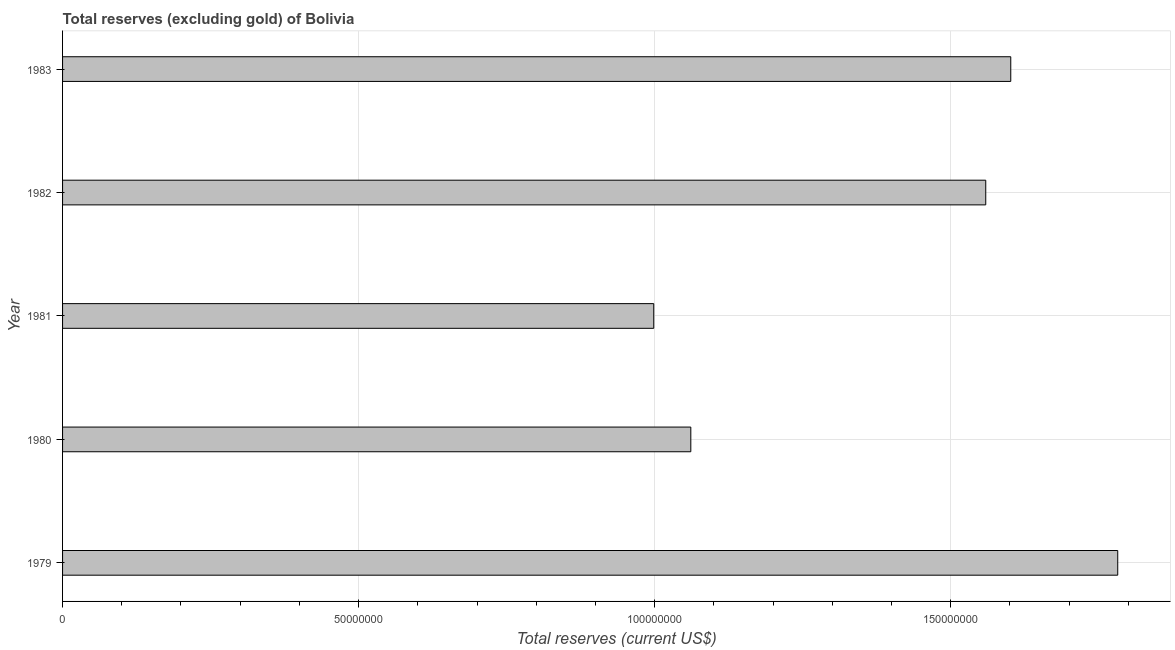Does the graph contain grids?
Offer a very short reply. Yes. What is the title of the graph?
Your answer should be very brief. Total reserves (excluding gold) of Bolivia. What is the label or title of the X-axis?
Provide a short and direct response. Total reserves (current US$). What is the label or title of the Y-axis?
Keep it short and to the point. Year. What is the total reserves (excluding gold) in 1982?
Keep it short and to the point. 1.56e+08. Across all years, what is the maximum total reserves (excluding gold)?
Your answer should be compact. 1.78e+08. Across all years, what is the minimum total reserves (excluding gold)?
Ensure brevity in your answer.  9.98e+07. In which year was the total reserves (excluding gold) maximum?
Keep it short and to the point. 1979. In which year was the total reserves (excluding gold) minimum?
Your answer should be very brief. 1981. What is the sum of the total reserves (excluding gold)?
Make the answer very short. 7.00e+08. What is the difference between the total reserves (excluding gold) in 1979 and 1982?
Offer a terse response. 2.23e+07. What is the average total reserves (excluding gold) per year?
Your answer should be compact. 1.40e+08. What is the median total reserves (excluding gold)?
Offer a very short reply. 1.56e+08. What is the ratio of the total reserves (excluding gold) in 1981 to that in 1983?
Provide a short and direct response. 0.62. Is the total reserves (excluding gold) in 1981 less than that in 1983?
Ensure brevity in your answer.  Yes. Is the difference between the total reserves (excluding gold) in 1979 and 1981 greater than the difference between any two years?
Your answer should be compact. Yes. What is the difference between the highest and the second highest total reserves (excluding gold)?
Offer a very short reply. 1.81e+07. Is the sum of the total reserves (excluding gold) in 1980 and 1981 greater than the maximum total reserves (excluding gold) across all years?
Your response must be concise. Yes. What is the difference between the highest and the lowest total reserves (excluding gold)?
Keep it short and to the point. 7.84e+07. In how many years, is the total reserves (excluding gold) greater than the average total reserves (excluding gold) taken over all years?
Make the answer very short. 3. How many bars are there?
Your answer should be very brief. 5. Are all the bars in the graph horizontal?
Offer a very short reply. Yes. Are the values on the major ticks of X-axis written in scientific E-notation?
Provide a succinct answer. No. What is the Total reserves (current US$) of 1979?
Make the answer very short. 1.78e+08. What is the Total reserves (current US$) of 1980?
Offer a terse response. 1.06e+08. What is the Total reserves (current US$) in 1981?
Make the answer very short. 9.98e+07. What is the Total reserves (current US$) of 1982?
Your answer should be very brief. 1.56e+08. What is the Total reserves (current US$) of 1983?
Your response must be concise. 1.60e+08. What is the difference between the Total reserves (current US$) in 1979 and 1980?
Keep it short and to the point. 7.21e+07. What is the difference between the Total reserves (current US$) in 1979 and 1981?
Your answer should be compact. 7.84e+07. What is the difference between the Total reserves (current US$) in 1979 and 1982?
Offer a very short reply. 2.23e+07. What is the difference between the Total reserves (current US$) in 1979 and 1983?
Your answer should be compact. 1.81e+07. What is the difference between the Total reserves (current US$) in 1980 and 1981?
Give a very brief answer. 6.26e+06. What is the difference between the Total reserves (current US$) in 1980 and 1982?
Your response must be concise. -4.98e+07. What is the difference between the Total reserves (current US$) in 1980 and 1983?
Make the answer very short. -5.40e+07. What is the difference between the Total reserves (current US$) in 1981 and 1982?
Ensure brevity in your answer.  -5.61e+07. What is the difference between the Total reserves (current US$) in 1981 and 1983?
Your answer should be very brief. -6.03e+07. What is the difference between the Total reserves (current US$) in 1982 and 1983?
Keep it short and to the point. -4.23e+06. What is the ratio of the Total reserves (current US$) in 1979 to that in 1980?
Your response must be concise. 1.68. What is the ratio of the Total reserves (current US$) in 1979 to that in 1981?
Make the answer very short. 1.78. What is the ratio of the Total reserves (current US$) in 1979 to that in 1982?
Offer a very short reply. 1.14. What is the ratio of the Total reserves (current US$) in 1979 to that in 1983?
Make the answer very short. 1.11. What is the ratio of the Total reserves (current US$) in 1980 to that in 1981?
Provide a succinct answer. 1.06. What is the ratio of the Total reserves (current US$) in 1980 to that in 1982?
Give a very brief answer. 0.68. What is the ratio of the Total reserves (current US$) in 1980 to that in 1983?
Ensure brevity in your answer.  0.66. What is the ratio of the Total reserves (current US$) in 1981 to that in 1982?
Offer a very short reply. 0.64. What is the ratio of the Total reserves (current US$) in 1981 to that in 1983?
Offer a terse response. 0.62. 